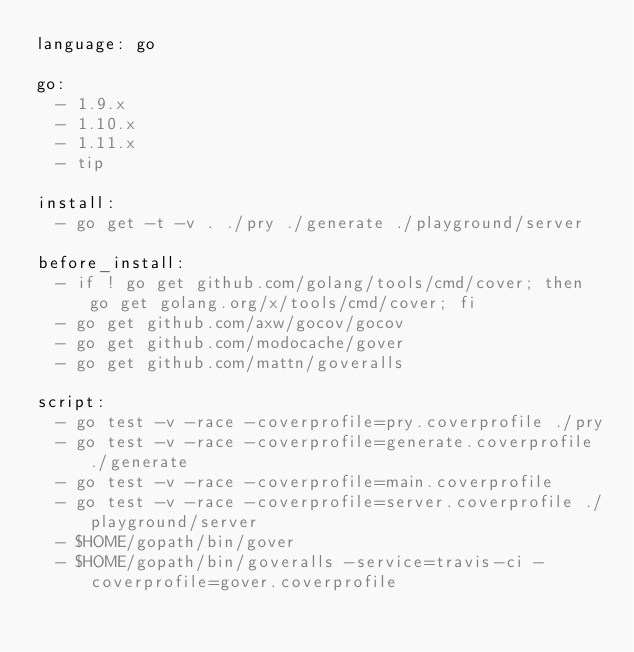Convert code to text. <code><loc_0><loc_0><loc_500><loc_500><_YAML_>language: go

go:
  - 1.9.x
  - 1.10.x
  - 1.11.x
  - tip

install:
  - go get -t -v . ./pry ./generate ./playground/server

before_install:
  - if ! go get github.com/golang/tools/cmd/cover; then go get golang.org/x/tools/cmd/cover; fi
  - go get github.com/axw/gocov/gocov
  - go get github.com/modocache/gover
  - go get github.com/mattn/goveralls

script:
  - go test -v -race -coverprofile=pry.coverprofile ./pry
  - go test -v -race -coverprofile=generate.coverprofile ./generate
  - go test -v -race -coverprofile=main.coverprofile
  - go test -v -race -coverprofile=server.coverprofile ./playground/server
  - $HOME/gopath/bin/gover
  - $HOME/gopath/bin/goveralls -service=travis-ci -coverprofile=gover.coverprofile
</code> 